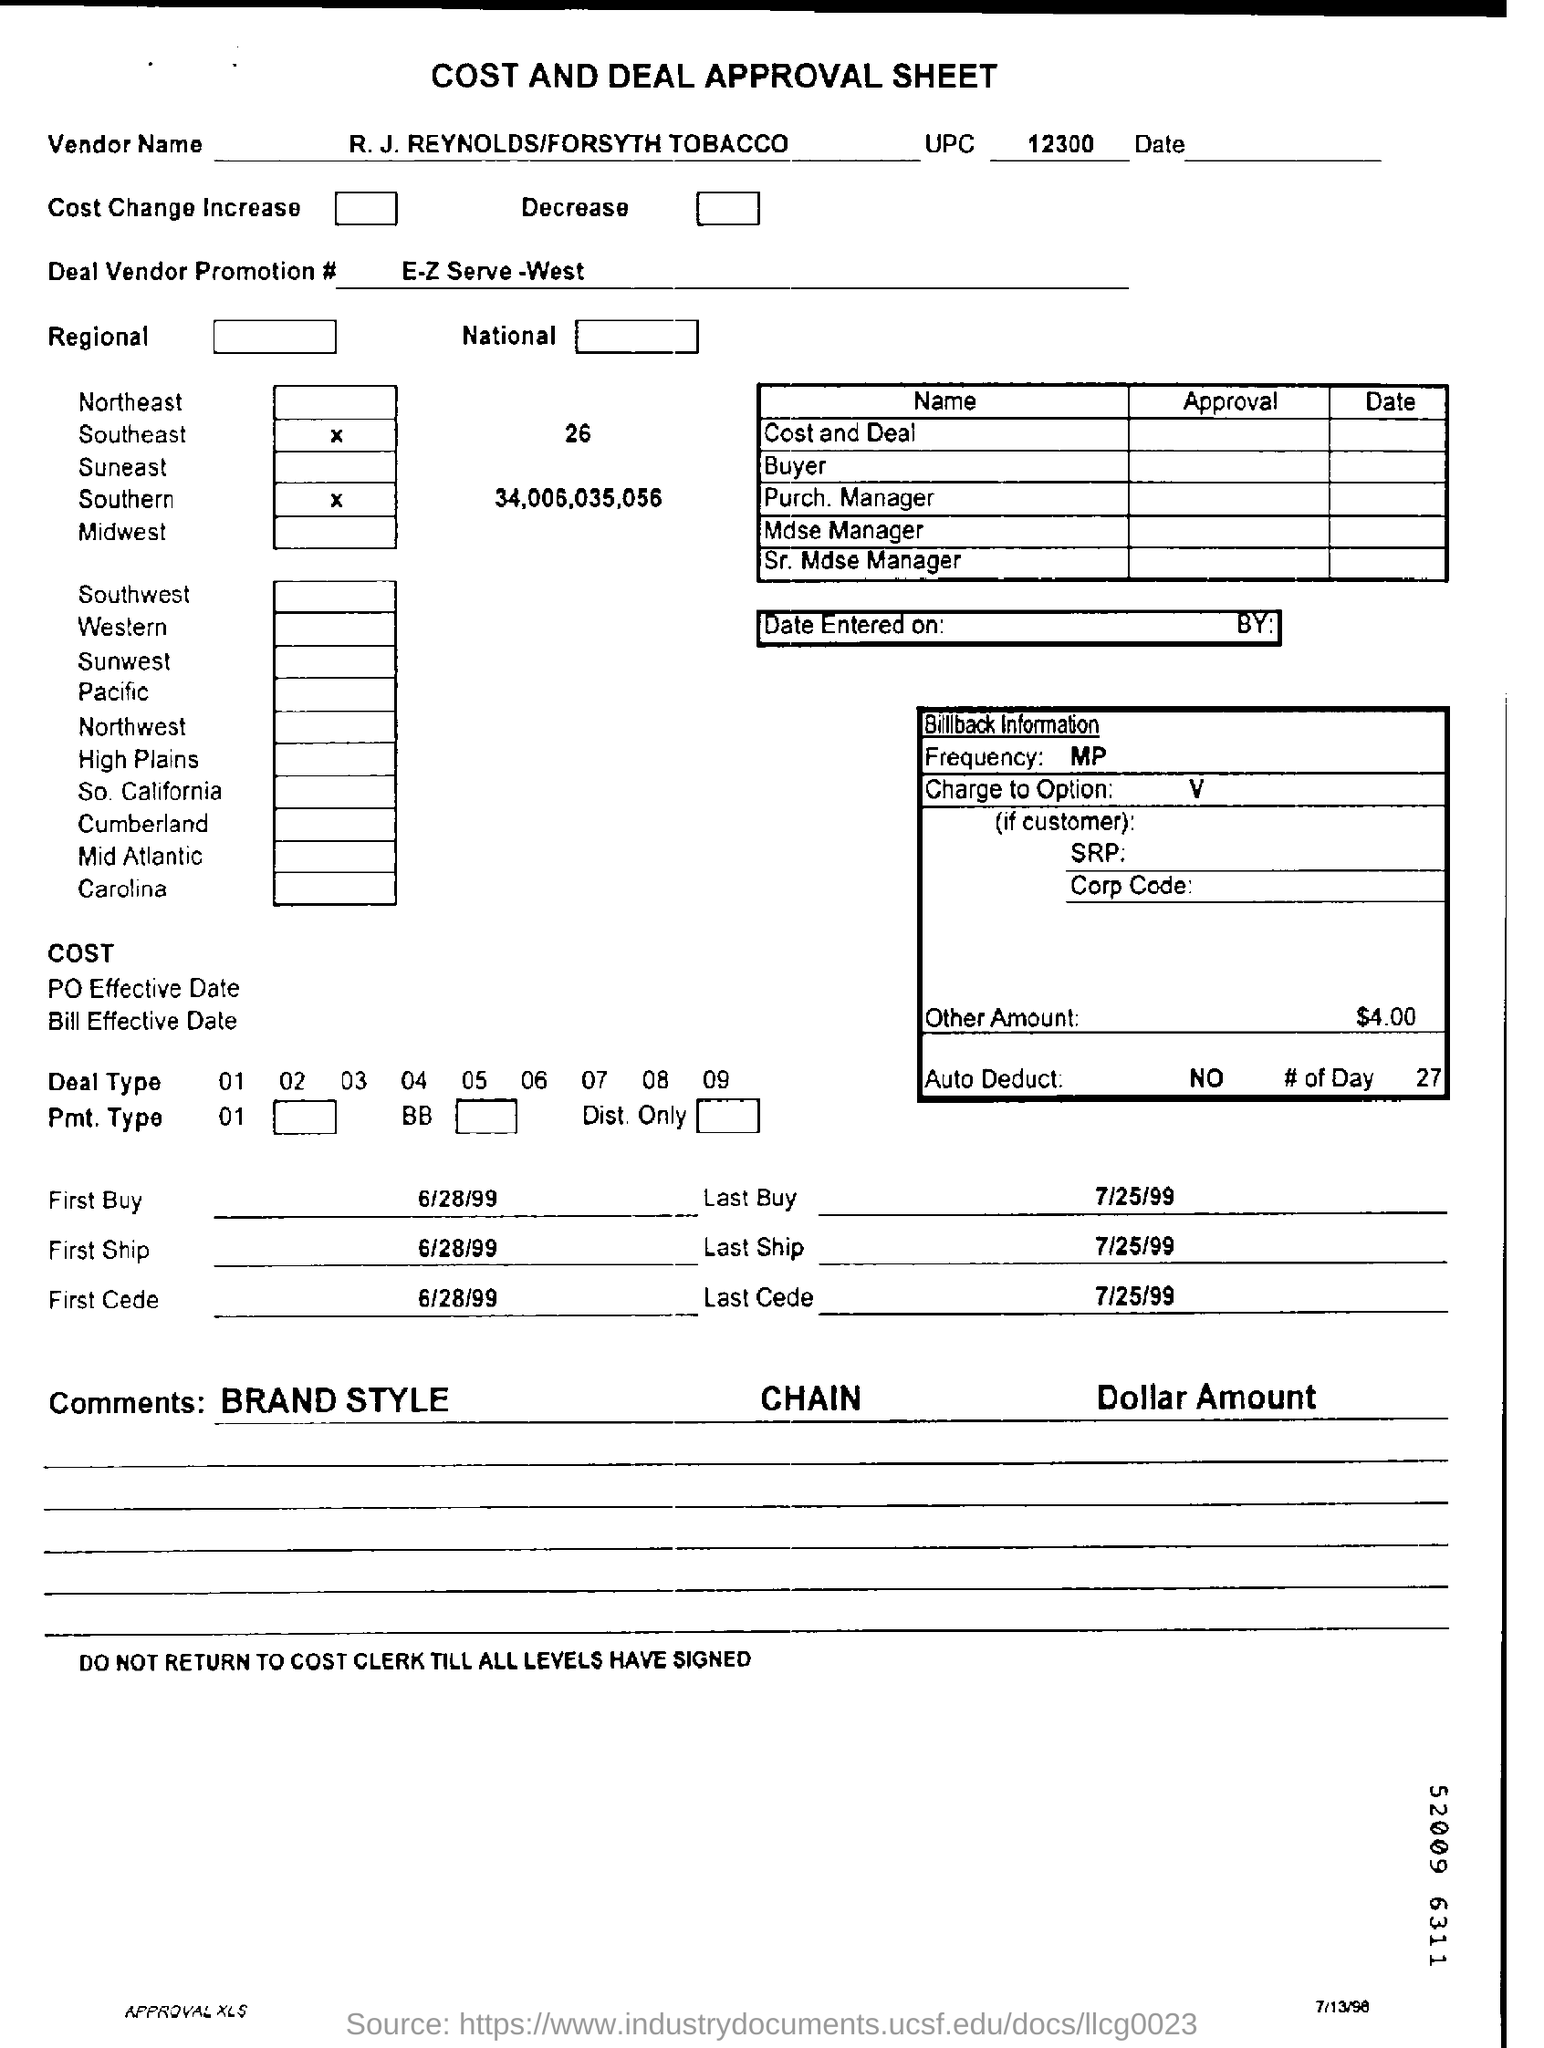What is the vendor name?
Your answer should be very brief. R. J. REYNOLDS/FORSYTH TOBACCO. What is the UPC?
Ensure brevity in your answer.  12300. What is the Deal Vendor Promotion #?
Offer a very short reply. E-Z Serve -West. What is the frequency?
Keep it short and to the point. MP. How much is the other amount mentioned?
Give a very brief answer. $4.00. 